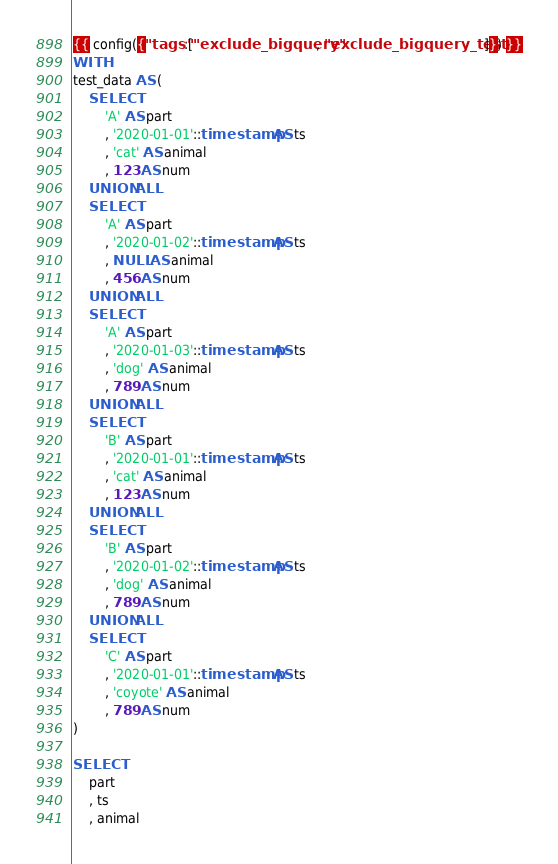Convert code to text. <code><loc_0><loc_0><loc_500><loc_500><_SQL_>{{ config({"tags":["exclude_bigquery", "exclude_bigquery_tests"]}) }}
WITH
test_data AS (
    SELECT
        'A' AS part
        , '2020-01-01'::timestamp AS ts
        , 'cat' AS animal
        , 123 AS num
    UNION ALL
    SELECT
        'A' AS part
        , '2020-01-02'::timestamp AS ts
        , NULL AS animal
        , 456 AS num
    UNION ALL
    SELECT
        'A' AS part
        , '2020-01-03'::timestamp AS ts
        , 'dog' AS animal
        , 789 AS num
    UNION ALL
    SELECT
        'B' AS part
        , '2020-01-01'::timestamp AS ts
        , 'cat' AS animal
        , 123 AS num
    UNION ALL
    SELECT
        'B' AS part
        , '2020-01-02'::timestamp AS ts
        , 'dog' AS animal
        , 789 AS num
    UNION ALL
    SELECT
        'C' AS part
        , '2020-01-01'::timestamp AS ts
        , 'coyote' AS animal
        , 789 AS num
)

SELECT
    part
    , ts
    , animal</code> 